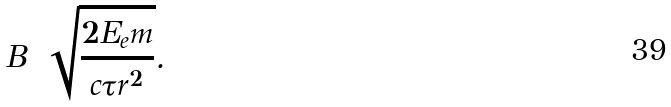<formula> <loc_0><loc_0><loc_500><loc_500>B = \sqrt { \frac { 2 E _ { e } m } { c \tau r ^ { 2 } } } .</formula> 